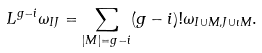<formula> <loc_0><loc_0><loc_500><loc_500>L ^ { g - i } \omega _ { I J } = \sum _ { | M | = g - i } ( g - i ) ! \omega _ { I \cup M , J \cup \iota M } .</formula> 